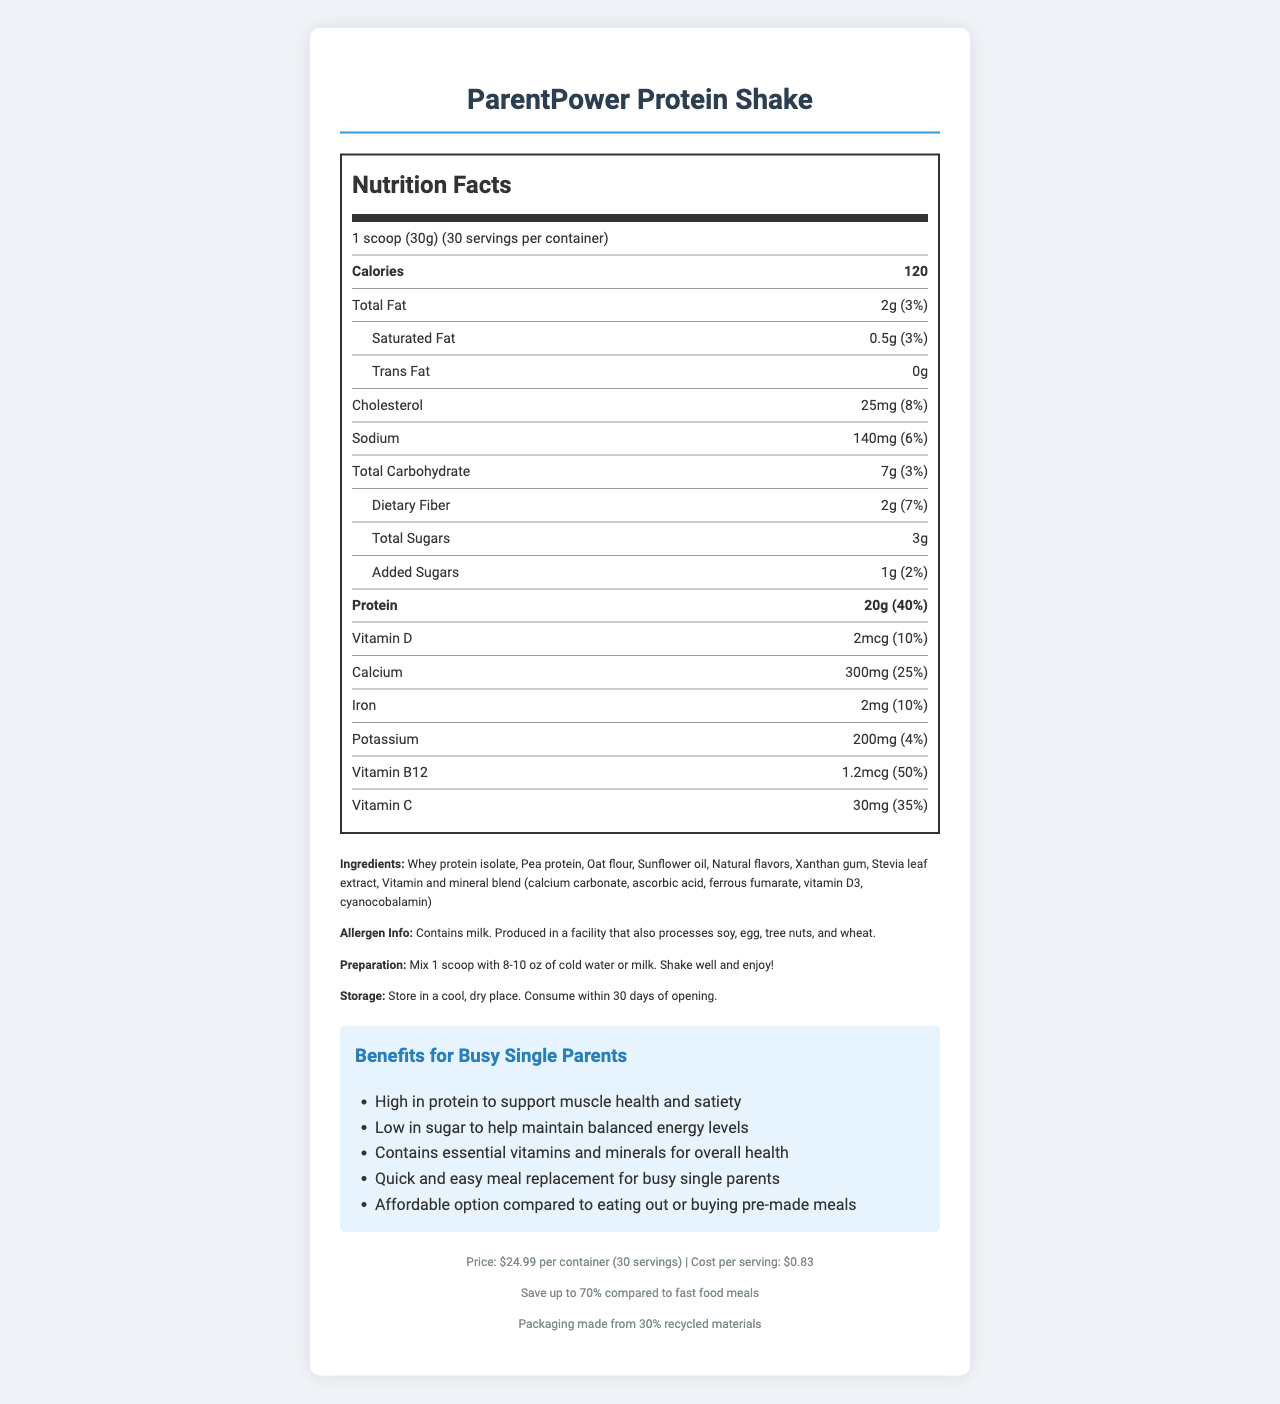which product is this document describing? The document title and contents refer specifically to the ParentPower Protein Shake.
Answer: ParentPower Protein Shake how many servings does one container have? The document mentions that one container has 30 servings.
Answer: 30 how many calories are in one serving? According to the Nutrition Facts, one serving contains 120 calories.
Answer: 120 what is the serving size? The serving size is listed as 1 scoop, which equals 30 grams.
Answer: 1 scoop (30g) what is the total amount of protein per serving? The nutrition label indicates 20 grams of protein per serving.
Answer: 20g what is the cost per serving? The document states that the cost per serving is $0.83.
Answer: $0.83 which type of fat is present in the highest amount? A. Saturated Fat B. Trans Fat C. Total Fat The document lists 2g of Total Fat, which is higher than the 0.5g of Saturated Fat and 0g of Trans Fat.
Answer: C. Total Fat how much dietary fiber does one serving contain? The nutrition label indicates that there are 2 grams of dietary fiber per serving.
Answer: 2g how much added sugar is in one serving? The added sugars are listed as 1 gram per serving.
Answer: 1g does this shake contain milk? The allergen info states, "Contains milk."
Answer: Yes what are some benefits of this product for busy single parents? The document lists these specific benefits as major points.
Answer: High in protein to support muscle health and satiety, low in sugar to help maintain balanced energy levels, contains essential vitamins and minerals for overall health, quick and easy meal replacement for busy single parents, affordable option compared to eating out or buying pre-made meals compare the amount of calcium in the shake to the daily value percentage. which one is correct? A. 10% B. 4% C. 25% The Nutrition Facts show that the calcium content is 300mg, which is 25% of the daily value.
Answer: C. 25% is the packaging made from recycled materials? The footer of the document states that the packaging is made from 30% recycled materials.
Answer: Yes summarize the main idea of the document. The document focuses on providing comprehensive details about the ParentPower Protein Shake, targeting the needs of single parents with nutritional values, preparation ease, and cost efficiency.
Answer: The document details the nutrition facts of the ParentPower Protein Shake, a budget-friendly, high-protein meal replacement designed for busy single parents. It highlights the nutritional content, ingredients, preparation instructions, benefits, cost, and sustainability aspects. what is the vitamin B12 content per serving? The nutrition label indicates that there are 1.2 micrograms of Vitamin B12 per serving.
Answer: 1.2mcg is the ParentPower Protein Shake gluten-free? The document does not explicitly state whether the product is gluten-free. The allergen info notes it is produced in a facility that also processes wheat, but this doesn't confirm if the shake itself is gluten-free.
Answer: Not enough information how should the shake be prepared? The document provides specific preparation instructions with these steps.
Answer: Mix 1 scoop with 8-10 oz of cold water or milk. Shake well and enjoy! where should the ParentPower Protein Shake be stored? The storage instructions detail that it should be kept in a cool, dry place and consumed within 30 days of opening.
Answer: Store in a cool, dry place. Consume within 30 days of opening. 